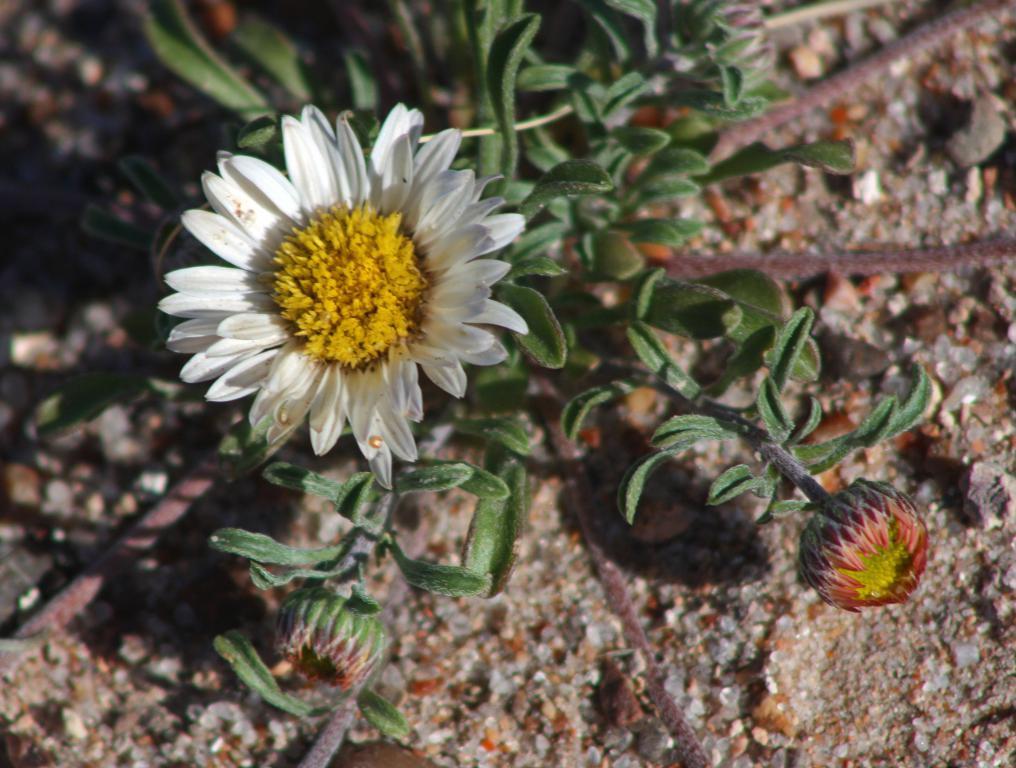Can you describe this image briefly? In the picture we can see a plant with two flowers to it and one is white in color and one is red in color and under the plant we can see a surface with stones. 